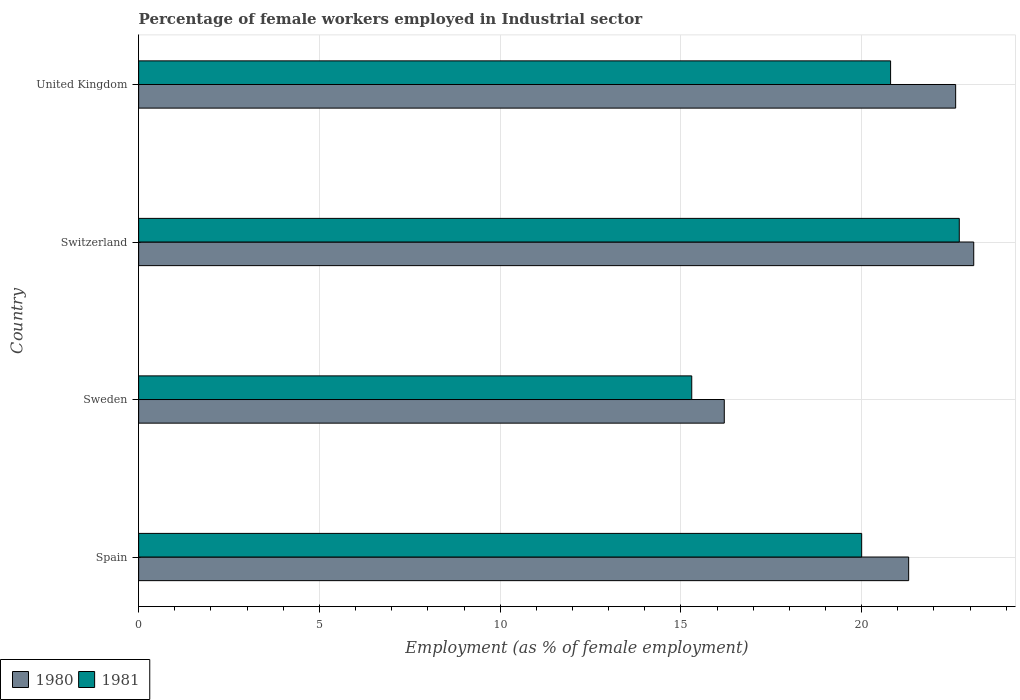How many different coloured bars are there?
Your answer should be compact. 2. How many groups of bars are there?
Provide a short and direct response. 4. Are the number of bars per tick equal to the number of legend labels?
Provide a short and direct response. Yes. How many bars are there on the 4th tick from the top?
Offer a terse response. 2. In how many cases, is the number of bars for a given country not equal to the number of legend labels?
Provide a short and direct response. 0. Across all countries, what is the maximum percentage of females employed in Industrial sector in 1981?
Provide a short and direct response. 22.7. Across all countries, what is the minimum percentage of females employed in Industrial sector in 1980?
Offer a very short reply. 16.2. In which country was the percentage of females employed in Industrial sector in 1981 maximum?
Your answer should be very brief. Switzerland. What is the total percentage of females employed in Industrial sector in 1980 in the graph?
Offer a very short reply. 83.2. What is the difference between the percentage of females employed in Industrial sector in 1981 in Spain and that in Sweden?
Ensure brevity in your answer.  4.7. What is the difference between the percentage of females employed in Industrial sector in 1980 in Switzerland and the percentage of females employed in Industrial sector in 1981 in Sweden?
Your answer should be very brief. 7.8. What is the average percentage of females employed in Industrial sector in 1980 per country?
Your response must be concise. 20.8. What is the difference between the percentage of females employed in Industrial sector in 1980 and percentage of females employed in Industrial sector in 1981 in United Kingdom?
Offer a terse response. 1.8. What is the ratio of the percentage of females employed in Industrial sector in 1981 in Spain to that in United Kingdom?
Ensure brevity in your answer.  0.96. Is the percentage of females employed in Industrial sector in 1980 in Sweden less than that in Switzerland?
Offer a terse response. Yes. What is the difference between the highest and the second highest percentage of females employed in Industrial sector in 1981?
Your answer should be very brief. 1.9. What is the difference between the highest and the lowest percentage of females employed in Industrial sector in 1980?
Offer a very short reply. 6.9. In how many countries, is the percentage of females employed in Industrial sector in 1980 greater than the average percentage of females employed in Industrial sector in 1980 taken over all countries?
Keep it short and to the point. 3. Is the sum of the percentage of females employed in Industrial sector in 1981 in Spain and Switzerland greater than the maximum percentage of females employed in Industrial sector in 1980 across all countries?
Offer a very short reply. Yes. What does the 1st bar from the top in United Kingdom represents?
Your response must be concise. 1981. What does the 2nd bar from the bottom in Sweden represents?
Offer a terse response. 1981. How many bars are there?
Provide a succinct answer. 8. Are all the bars in the graph horizontal?
Provide a short and direct response. Yes. What is the difference between two consecutive major ticks on the X-axis?
Your answer should be very brief. 5. Are the values on the major ticks of X-axis written in scientific E-notation?
Provide a succinct answer. No. Does the graph contain any zero values?
Offer a terse response. No. Does the graph contain grids?
Make the answer very short. Yes. How many legend labels are there?
Offer a terse response. 2. How are the legend labels stacked?
Make the answer very short. Horizontal. What is the title of the graph?
Ensure brevity in your answer.  Percentage of female workers employed in Industrial sector. Does "1972" appear as one of the legend labels in the graph?
Ensure brevity in your answer.  No. What is the label or title of the X-axis?
Offer a terse response. Employment (as % of female employment). What is the label or title of the Y-axis?
Your answer should be compact. Country. What is the Employment (as % of female employment) of 1980 in Spain?
Your response must be concise. 21.3. What is the Employment (as % of female employment) in 1981 in Spain?
Your answer should be very brief. 20. What is the Employment (as % of female employment) of 1980 in Sweden?
Offer a terse response. 16.2. What is the Employment (as % of female employment) in 1981 in Sweden?
Ensure brevity in your answer.  15.3. What is the Employment (as % of female employment) of 1980 in Switzerland?
Offer a very short reply. 23.1. What is the Employment (as % of female employment) of 1981 in Switzerland?
Provide a short and direct response. 22.7. What is the Employment (as % of female employment) in 1980 in United Kingdom?
Offer a very short reply. 22.6. What is the Employment (as % of female employment) of 1981 in United Kingdom?
Your response must be concise. 20.8. Across all countries, what is the maximum Employment (as % of female employment) of 1980?
Ensure brevity in your answer.  23.1. Across all countries, what is the maximum Employment (as % of female employment) in 1981?
Offer a terse response. 22.7. Across all countries, what is the minimum Employment (as % of female employment) in 1980?
Your response must be concise. 16.2. Across all countries, what is the minimum Employment (as % of female employment) of 1981?
Give a very brief answer. 15.3. What is the total Employment (as % of female employment) in 1980 in the graph?
Offer a very short reply. 83.2. What is the total Employment (as % of female employment) in 1981 in the graph?
Give a very brief answer. 78.8. What is the difference between the Employment (as % of female employment) in 1981 in Spain and that in Sweden?
Provide a succinct answer. 4.7. What is the difference between the Employment (as % of female employment) in 1981 in Spain and that in Switzerland?
Give a very brief answer. -2.7. What is the difference between the Employment (as % of female employment) of 1980 in Spain and that in United Kingdom?
Keep it short and to the point. -1.3. What is the difference between the Employment (as % of female employment) in 1980 in Sweden and that in Switzerland?
Make the answer very short. -6.9. What is the difference between the Employment (as % of female employment) in 1980 in Sweden and that in United Kingdom?
Make the answer very short. -6.4. What is the difference between the Employment (as % of female employment) of 1980 in Switzerland and that in United Kingdom?
Offer a very short reply. 0.5. What is the difference between the Employment (as % of female employment) of 1980 in Spain and the Employment (as % of female employment) of 1981 in Sweden?
Offer a terse response. 6. What is the average Employment (as % of female employment) of 1980 per country?
Ensure brevity in your answer.  20.8. What is the difference between the Employment (as % of female employment) of 1980 and Employment (as % of female employment) of 1981 in Sweden?
Your answer should be compact. 0.9. What is the difference between the Employment (as % of female employment) in 1980 and Employment (as % of female employment) in 1981 in Switzerland?
Offer a very short reply. 0.4. What is the ratio of the Employment (as % of female employment) in 1980 in Spain to that in Sweden?
Offer a terse response. 1.31. What is the ratio of the Employment (as % of female employment) in 1981 in Spain to that in Sweden?
Make the answer very short. 1.31. What is the ratio of the Employment (as % of female employment) in 1980 in Spain to that in Switzerland?
Offer a terse response. 0.92. What is the ratio of the Employment (as % of female employment) of 1981 in Spain to that in Switzerland?
Provide a short and direct response. 0.88. What is the ratio of the Employment (as % of female employment) of 1980 in Spain to that in United Kingdom?
Give a very brief answer. 0.94. What is the ratio of the Employment (as % of female employment) in 1981 in Spain to that in United Kingdom?
Keep it short and to the point. 0.96. What is the ratio of the Employment (as % of female employment) of 1980 in Sweden to that in Switzerland?
Offer a very short reply. 0.7. What is the ratio of the Employment (as % of female employment) of 1981 in Sweden to that in Switzerland?
Your response must be concise. 0.67. What is the ratio of the Employment (as % of female employment) of 1980 in Sweden to that in United Kingdom?
Offer a very short reply. 0.72. What is the ratio of the Employment (as % of female employment) in 1981 in Sweden to that in United Kingdom?
Ensure brevity in your answer.  0.74. What is the ratio of the Employment (as % of female employment) in 1980 in Switzerland to that in United Kingdom?
Provide a short and direct response. 1.02. What is the ratio of the Employment (as % of female employment) in 1981 in Switzerland to that in United Kingdom?
Your response must be concise. 1.09. What is the difference between the highest and the second highest Employment (as % of female employment) of 1980?
Offer a terse response. 0.5. What is the difference between the highest and the lowest Employment (as % of female employment) in 1980?
Offer a very short reply. 6.9. 